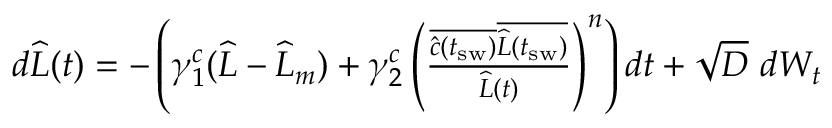<formula> <loc_0><loc_0><loc_500><loc_500>\begin{array} { r } { d \widehat { L } ( t ) = - \left ( \gamma _ { 1 } ^ { c } ( \widehat { L } - \widehat { L } _ { m } ) + \gamma _ { 2 } ^ { c } \left ( \frac { \overline { { \widehat { c } ( t _ { s w } ) } } \overline { { \widehat { L } ( t _ { s w } ) } } } { \widehat { L } ( t ) } \right ) ^ { n } \right ) d t + \sqrt { D } \ d W _ { t } } \end{array}</formula> 